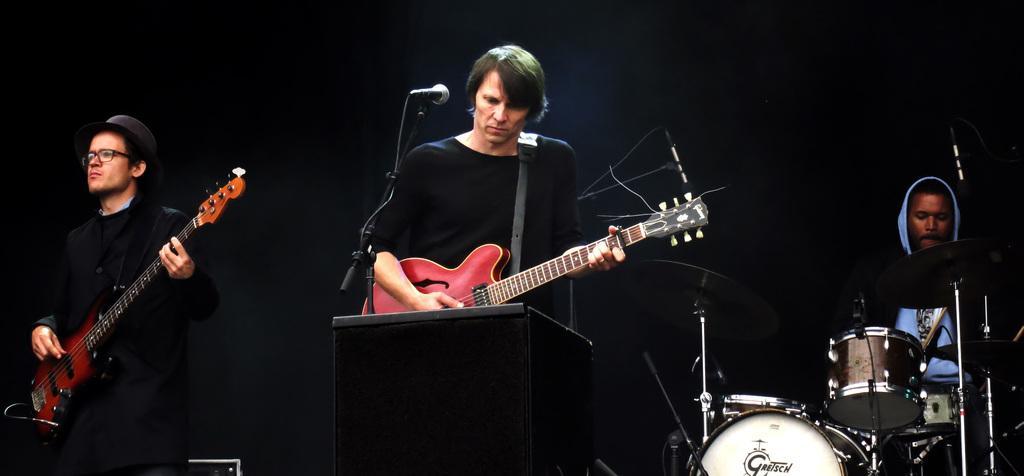Please provide a concise description of this image. In this picture I can see there are three persons and two of them are playing the guitar, there are micro phones in front of them. On to right there is a person sitting and playing the drum set and the backdrop is dark. 